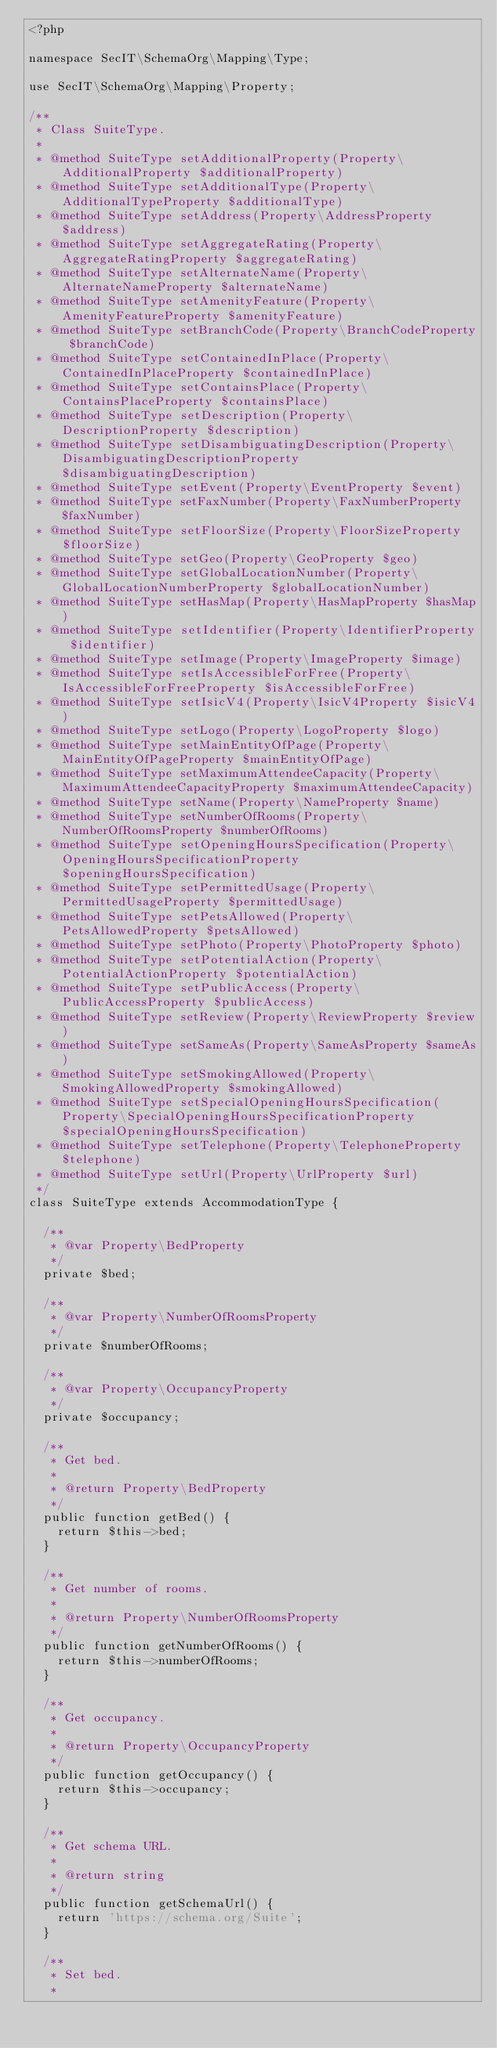<code> <loc_0><loc_0><loc_500><loc_500><_PHP_><?php

namespace SecIT\SchemaOrg\Mapping\Type;

use SecIT\SchemaOrg\Mapping\Property;

/**
 * Class SuiteType.
 * 
 * @method SuiteType setAdditionalProperty(Property\AdditionalProperty $additionalProperty)
 * @method SuiteType setAdditionalType(Property\AdditionalTypeProperty $additionalType)
 * @method SuiteType setAddress(Property\AddressProperty $address)
 * @method SuiteType setAggregateRating(Property\AggregateRatingProperty $aggregateRating)
 * @method SuiteType setAlternateName(Property\AlternateNameProperty $alternateName)
 * @method SuiteType setAmenityFeature(Property\AmenityFeatureProperty $amenityFeature)
 * @method SuiteType setBranchCode(Property\BranchCodeProperty $branchCode)
 * @method SuiteType setContainedInPlace(Property\ContainedInPlaceProperty $containedInPlace)
 * @method SuiteType setContainsPlace(Property\ContainsPlaceProperty $containsPlace)
 * @method SuiteType setDescription(Property\DescriptionProperty $description)
 * @method SuiteType setDisambiguatingDescription(Property\DisambiguatingDescriptionProperty $disambiguatingDescription)
 * @method SuiteType setEvent(Property\EventProperty $event)
 * @method SuiteType setFaxNumber(Property\FaxNumberProperty $faxNumber)
 * @method SuiteType setFloorSize(Property\FloorSizeProperty $floorSize)
 * @method SuiteType setGeo(Property\GeoProperty $geo)
 * @method SuiteType setGlobalLocationNumber(Property\GlobalLocationNumberProperty $globalLocationNumber)
 * @method SuiteType setHasMap(Property\HasMapProperty $hasMap)
 * @method SuiteType setIdentifier(Property\IdentifierProperty $identifier)
 * @method SuiteType setImage(Property\ImageProperty $image)
 * @method SuiteType setIsAccessibleForFree(Property\IsAccessibleForFreeProperty $isAccessibleForFree)
 * @method SuiteType setIsicV4(Property\IsicV4Property $isicV4)
 * @method SuiteType setLogo(Property\LogoProperty $logo)
 * @method SuiteType setMainEntityOfPage(Property\MainEntityOfPageProperty $mainEntityOfPage)
 * @method SuiteType setMaximumAttendeeCapacity(Property\MaximumAttendeeCapacityProperty $maximumAttendeeCapacity)
 * @method SuiteType setName(Property\NameProperty $name)
 * @method SuiteType setNumberOfRooms(Property\NumberOfRoomsProperty $numberOfRooms)
 * @method SuiteType setOpeningHoursSpecification(Property\OpeningHoursSpecificationProperty $openingHoursSpecification)
 * @method SuiteType setPermittedUsage(Property\PermittedUsageProperty $permittedUsage)
 * @method SuiteType setPetsAllowed(Property\PetsAllowedProperty $petsAllowed)
 * @method SuiteType setPhoto(Property\PhotoProperty $photo)
 * @method SuiteType setPotentialAction(Property\PotentialActionProperty $potentialAction)
 * @method SuiteType setPublicAccess(Property\PublicAccessProperty $publicAccess)
 * @method SuiteType setReview(Property\ReviewProperty $review)
 * @method SuiteType setSameAs(Property\SameAsProperty $sameAs)
 * @method SuiteType setSmokingAllowed(Property\SmokingAllowedProperty $smokingAllowed)
 * @method SuiteType setSpecialOpeningHoursSpecification(Property\SpecialOpeningHoursSpecificationProperty $specialOpeningHoursSpecification)
 * @method SuiteType setTelephone(Property\TelephoneProperty $telephone)
 * @method SuiteType setUrl(Property\UrlProperty $url)
 */
class SuiteType extends AccommodationType {

	/**
	 * @var Property\BedProperty
	 */
	private $bed;

	/**
	 * @var Property\NumberOfRoomsProperty
	 */
	private $numberOfRooms;

	/**
	 * @var Property\OccupancyProperty
	 */
	private $occupancy;

	/**
	 * Get bed.
	 * 
	 * @return Property\BedProperty
	 */
	public function getBed() {
		return $this->bed;
	}

	/**
	 * Get number of rooms.
	 * 
	 * @return Property\NumberOfRoomsProperty
	 */
	public function getNumberOfRooms() {
		return $this->numberOfRooms;
	}

	/**
	 * Get occupancy.
	 * 
	 * @return Property\OccupancyProperty
	 */
	public function getOccupancy() {
		return $this->occupancy;
	}

	/**
	 * Get schema URL.
	 * 
	 * @return string
	 */
	public function getSchemaUrl() {
		return 'https://schema.org/Suite';
	}

	/**
	 * Set bed.
	 * </code> 